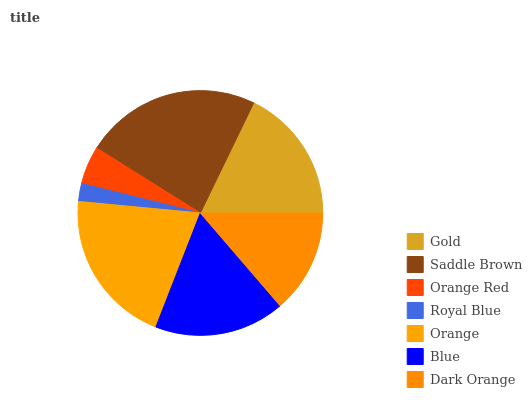Is Royal Blue the minimum?
Answer yes or no. Yes. Is Saddle Brown the maximum?
Answer yes or no. Yes. Is Orange Red the minimum?
Answer yes or no. No. Is Orange Red the maximum?
Answer yes or no. No. Is Saddle Brown greater than Orange Red?
Answer yes or no. Yes. Is Orange Red less than Saddle Brown?
Answer yes or no. Yes. Is Orange Red greater than Saddle Brown?
Answer yes or no. No. Is Saddle Brown less than Orange Red?
Answer yes or no. No. Is Blue the high median?
Answer yes or no. Yes. Is Blue the low median?
Answer yes or no. Yes. Is Saddle Brown the high median?
Answer yes or no. No. Is Royal Blue the low median?
Answer yes or no. No. 